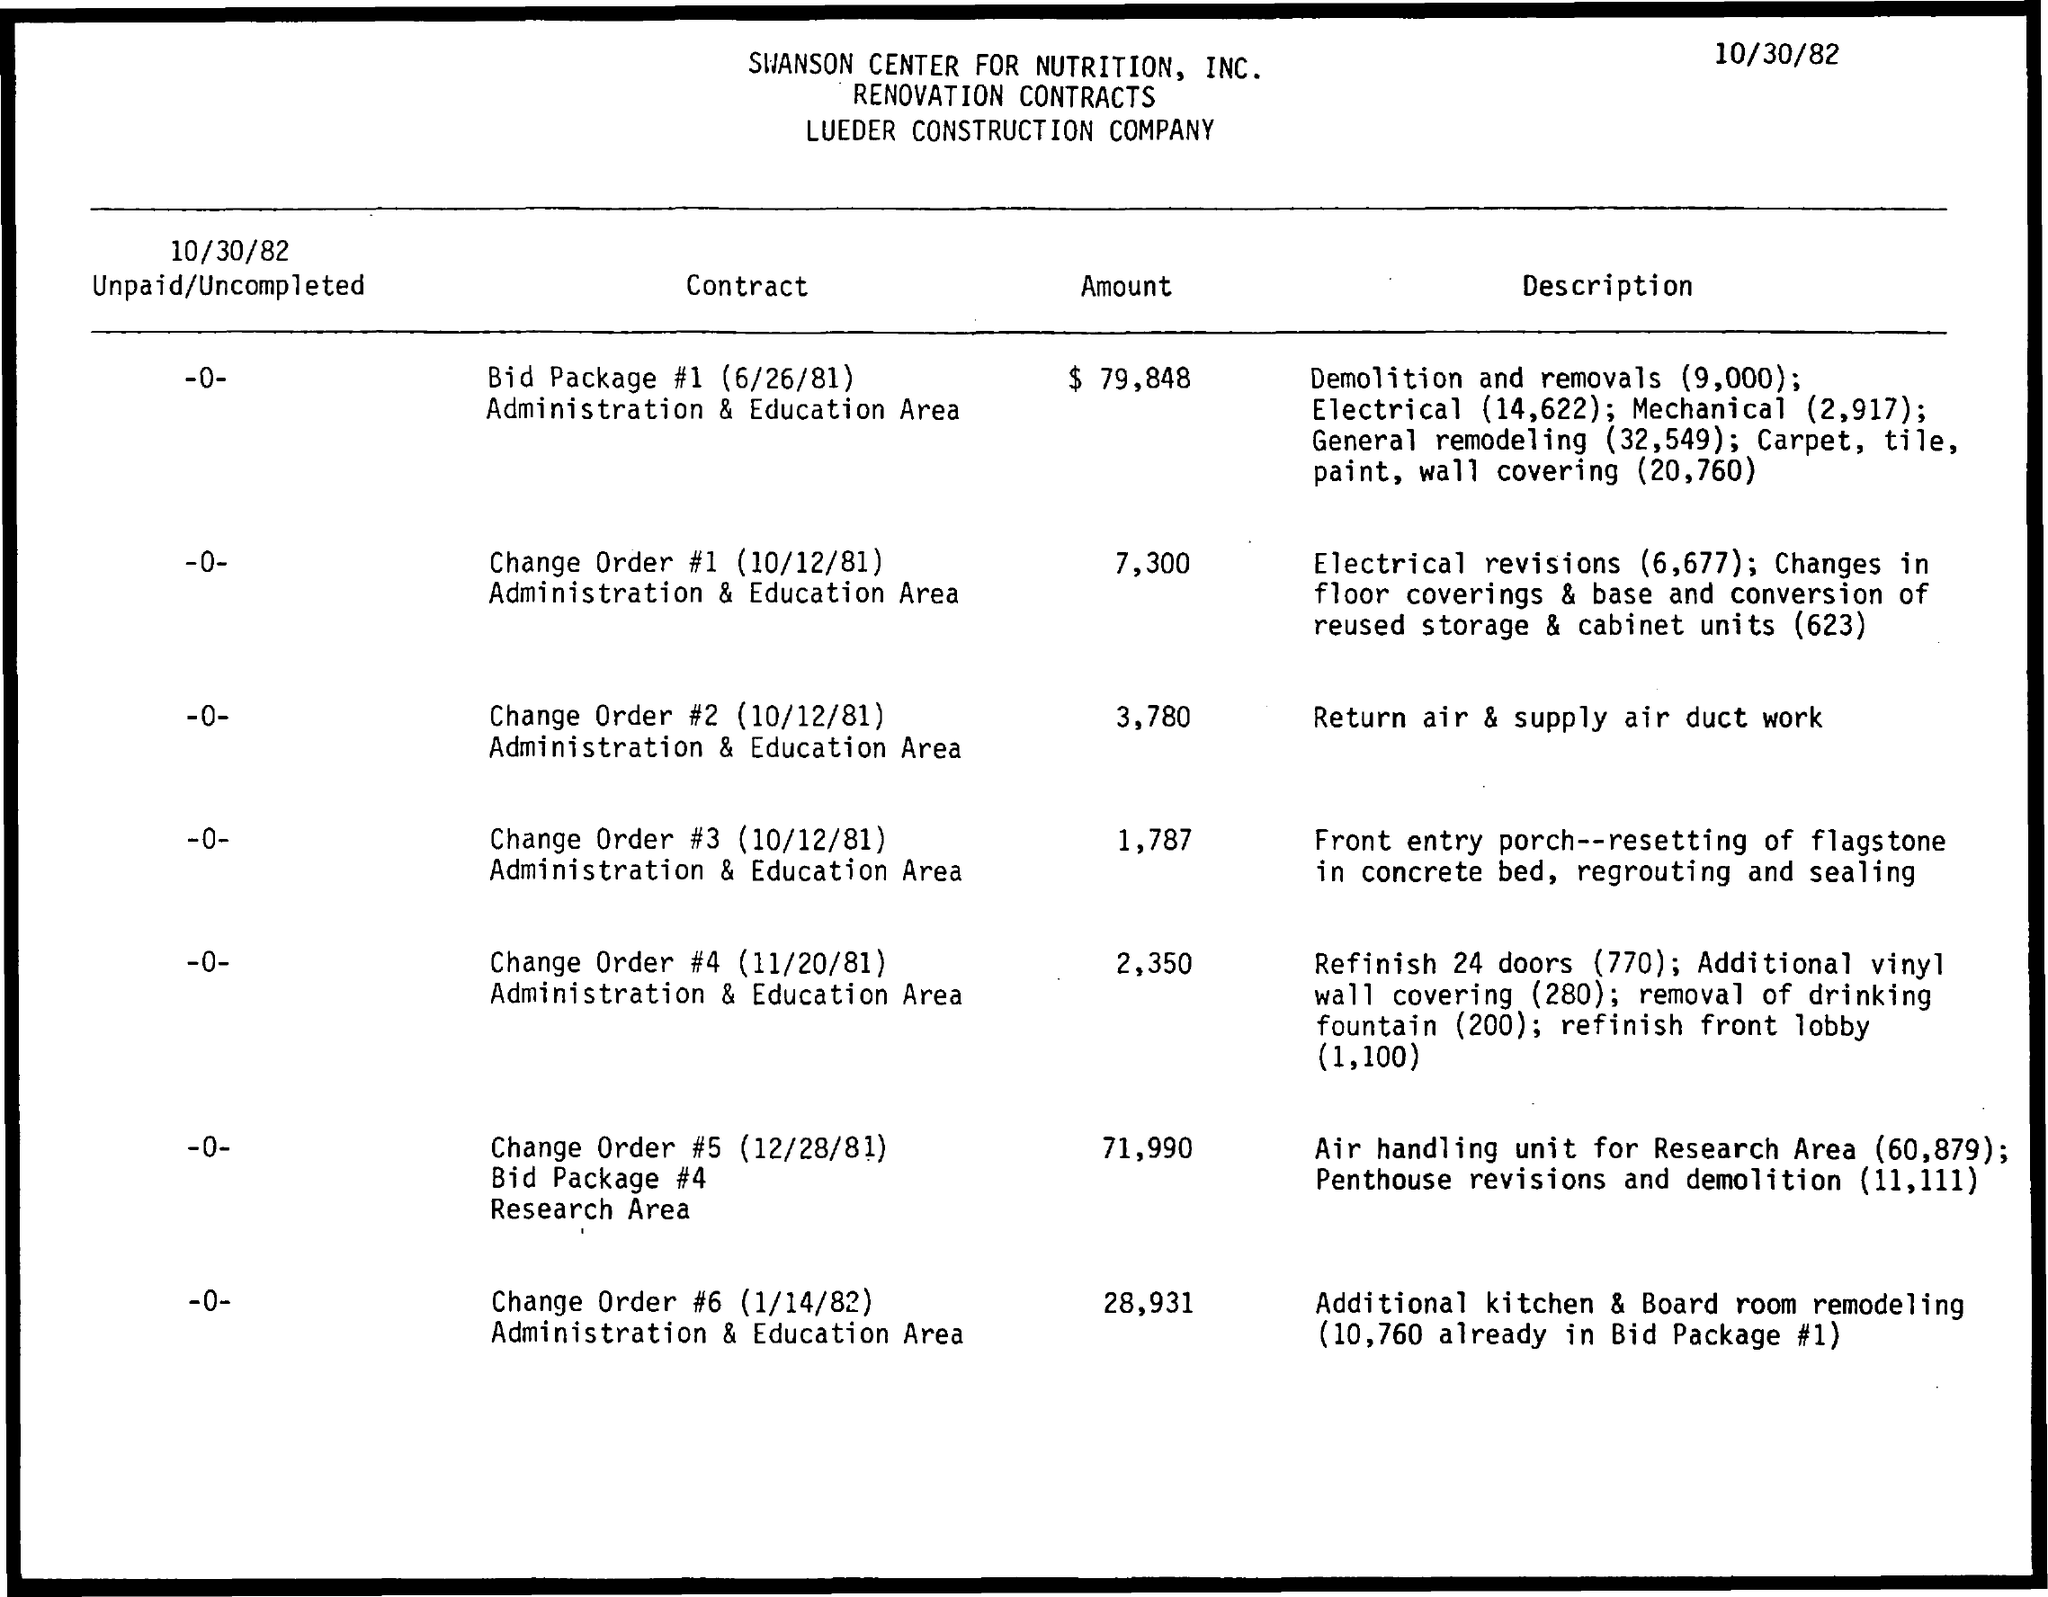What is the date on the document?
Keep it short and to the point. 10/30/82. What is the Amount for Change Order #5 (12/28/81) Bid package #4 Research Area?
Offer a terse response. 71,990. 